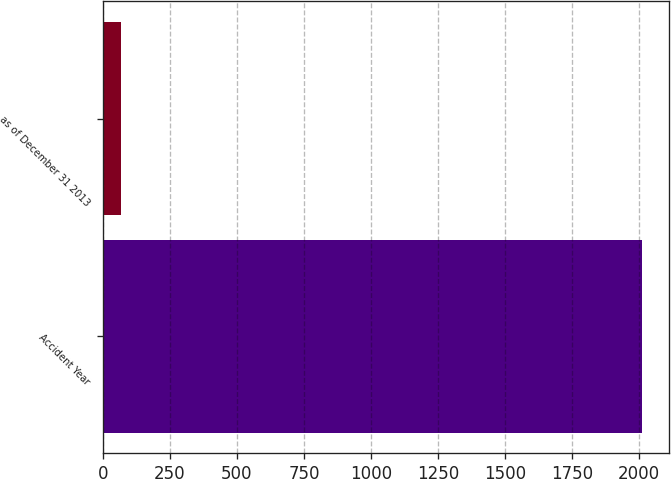Convert chart. <chart><loc_0><loc_0><loc_500><loc_500><bar_chart><fcel>Accident Year<fcel>as of December 31 2013<nl><fcel>2011<fcel>67<nl></chart> 